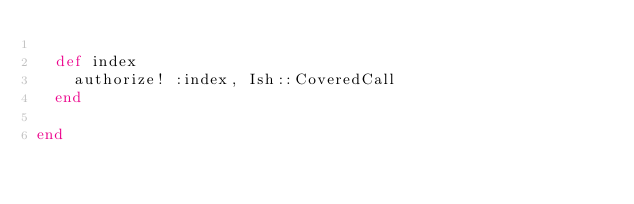<code> <loc_0><loc_0><loc_500><loc_500><_Ruby_>
  def index
    authorize! :index, Ish::CoveredCall
  end

end

</code> 